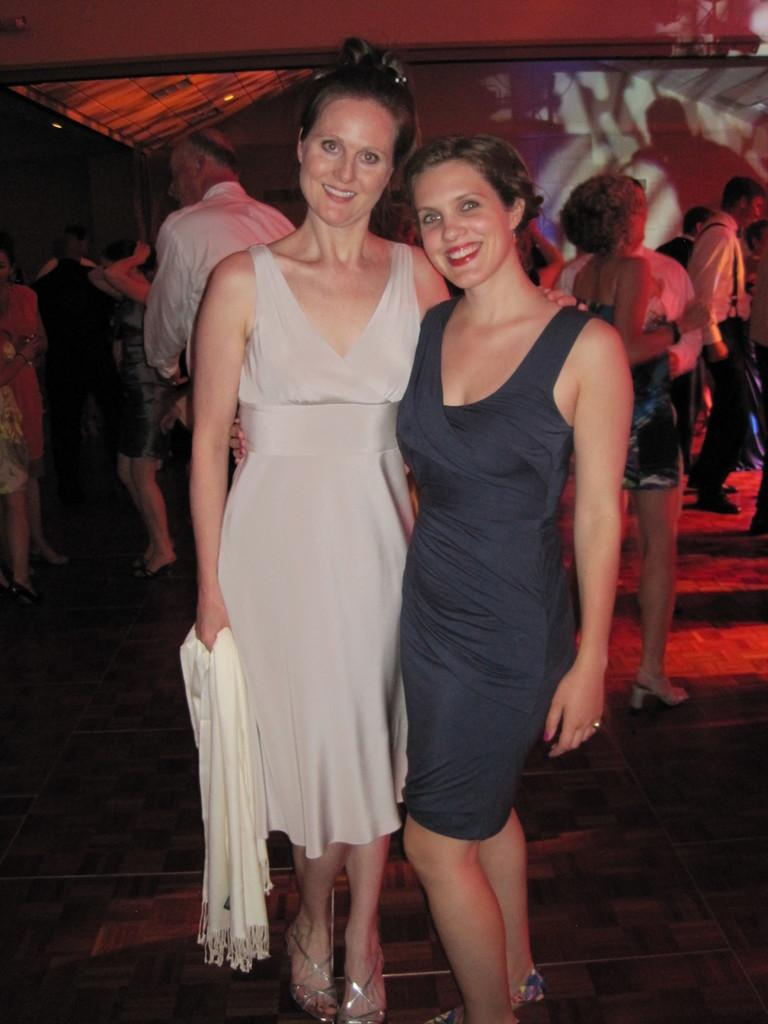How many women are in the image? There are two women standing in the image. What are the women doing in the image? The women are looking at something and smiling. What is one of the women holding? One woman is holding a cloth. Can you describe the background of the image? There is a group of people in the background of the image. What type of marble is visible in the image? There is no marble present in the image. How does the behavior of the women in the image reflect their cultural background? The image does not provide enough information to determine the cultural background or behavior of the women. 